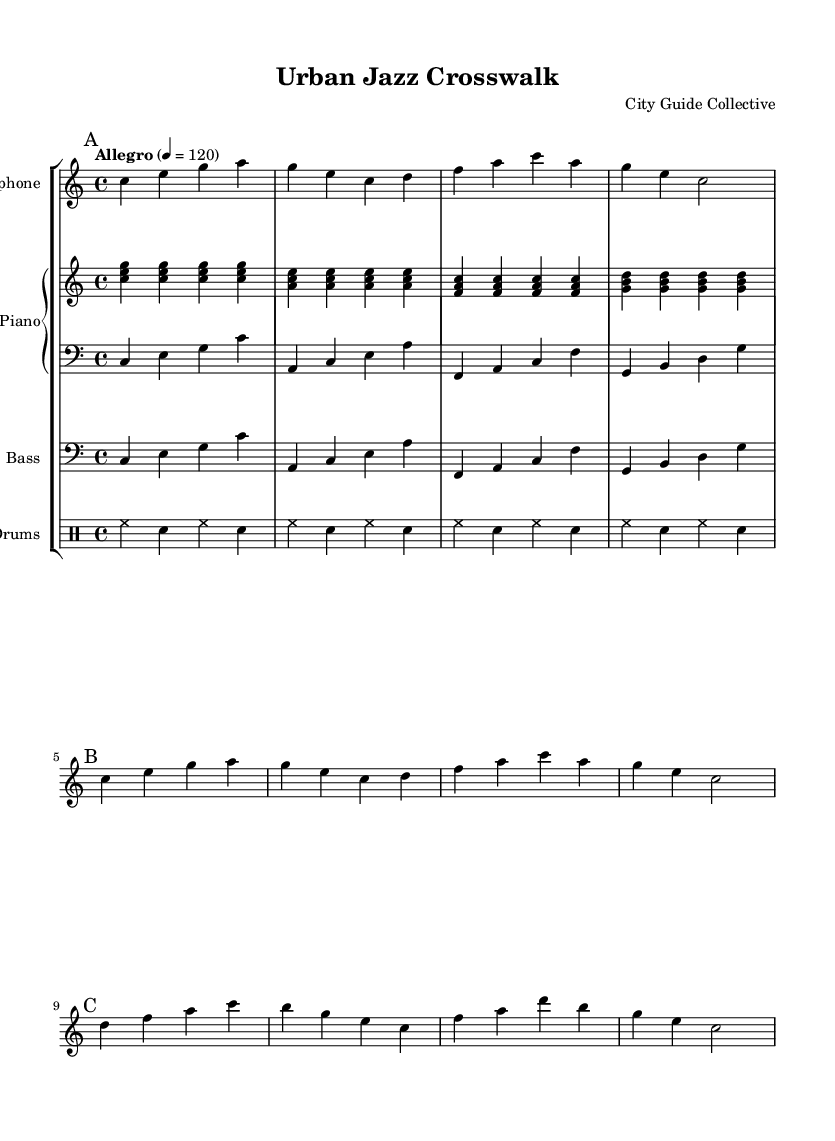What is the key signature of this music? The key signature in the score shows there are no sharps or flats, indicating it is in C major.
Answer: C major What is the time signature of this music? The time signature in the score is displayed as 4/4, which indicates there are four beats in a measure and the quarter note gets one beat.
Answer: 4/4 What is the tempo marking for this piece? The tempo marking in the score indicates "Allegro" with a metronome marking of 120 beats per minute, meaning it should be played fast and lively.
Answer: Allegro, 120 How many measures are in section A? Counting the measures in section A, which starts with a mark "A" and ends before the mark "B", there are 4 measures present.
Answer: 4 What instruments are included in this arrangement? The score lists four instruments: Saxophone, Piano (with right and left hands), Bass, and Drums, each labeled on their respective staves.
Answer: Saxophone, Piano, Bass, Drums Which section contains a descending melodic line? In section C, the saxophone part shows a descending sequence from d to c, indicating a downward melodic motion.
Answer: Section C How does the rhythm of the drums contribute to the urban feel of the piece? The drum pattern features consistent hi-hat and snare hits in a repetitive rhythm, likely evoking the busy, rhythmic atmosphere of city life.
Answer: Consistent hi-hat and snare pattern 